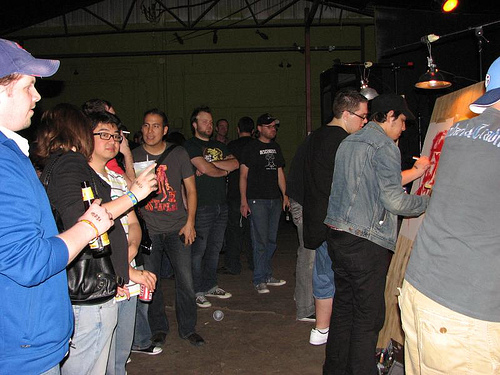<image>
Can you confirm if the man is behind the cup? Yes. From this viewpoint, the man is positioned behind the cup, with the cup partially or fully occluding the man. 